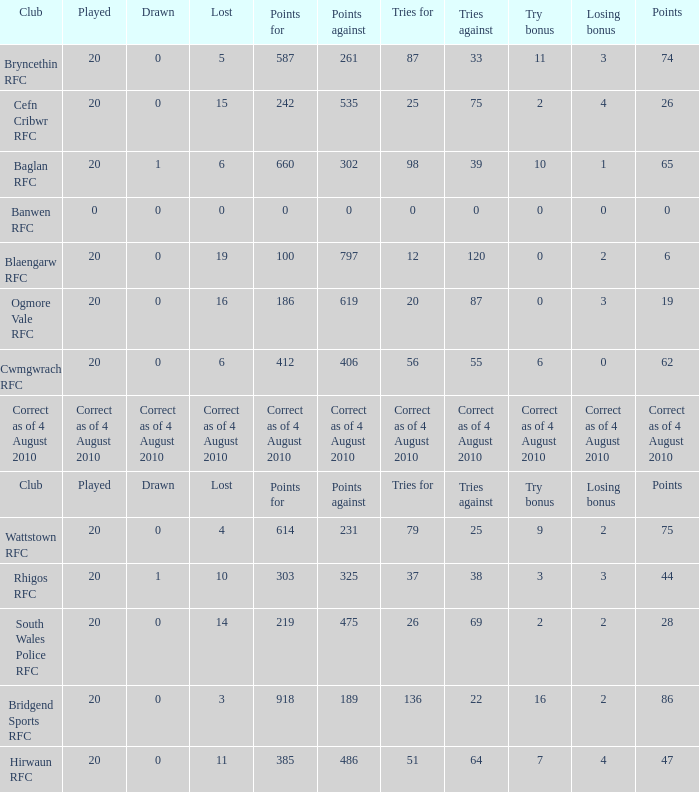Give me the full table as a dictionary. {'header': ['Club', 'Played', 'Drawn', 'Lost', 'Points for', 'Points against', 'Tries for', 'Tries against', 'Try bonus', 'Losing bonus', 'Points'], 'rows': [['Bryncethin RFC', '20', '0', '5', '587', '261', '87', '33', '11', '3', '74'], ['Cefn Cribwr RFC', '20', '0', '15', '242', '535', '25', '75', '2', '4', '26'], ['Baglan RFC', '20', '1', '6', '660', '302', '98', '39', '10', '1', '65'], ['Banwen RFC', '0', '0', '0', '0', '0', '0', '0', '0', '0', '0'], ['Blaengarw RFC', '20', '0', '19', '100', '797', '12', '120', '0', '2', '6'], ['Ogmore Vale RFC', '20', '0', '16', '186', '619', '20', '87', '0', '3', '19'], ['Cwmgwrach RFC', '20', '0', '6', '412', '406', '56', '55', '6', '0', '62'], ['Correct as of 4 August 2010', 'Correct as of 4 August 2010', 'Correct as of 4 August 2010', 'Correct as of 4 August 2010', 'Correct as of 4 August 2010', 'Correct as of 4 August 2010', 'Correct as of 4 August 2010', 'Correct as of 4 August 2010', 'Correct as of 4 August 2010', 'Correct as of 4 August 2010', 'Correct as of 4 August 2010'], ['Club', 'Played', 'Drawn', 'Lost', 'Points for', 'Points against', 'Tries for', 'Tries against', 'Try bonus', 'Losing bonus', 'Points'], ['Wattstown RFC', '20', '0', '4', '614', '231', '79', '25', '9', '2', '75'], ['Rhigos RFC', '20', '1', '10', '303', '325', '37', '38', '3', '3', '44'], ['South Wales Police RFC', '20', '0', '14', '219', '475', '26', '69', '2', '2', '28'], ['Bridgend Sports RFC', '20', '0', '3', '918', '189', '136', '22', '16', '2', '86'], ['Hirwaun RFC', '20', '0', '11', '385', '486', '51', '64', '7', '4', '47']]} What is drawn when the club is hirwaun rfc? 0.0. 